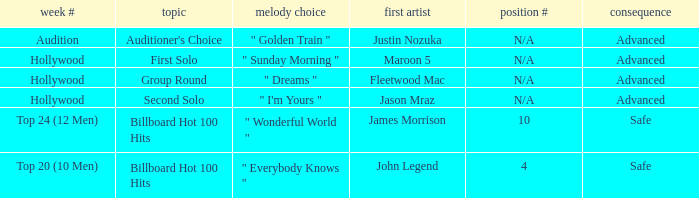What are all the week numbers where the subject matter is the auditioner's selection? Audition. 